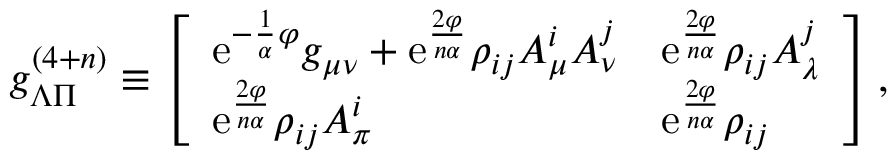Convert formula to latex. <formula><loc_0><loc_0><loc_500><loc_500>g _ { \Lambda \Pi } ^ { ( 4 + n ) } \equiv \left [ \begin{array} { l l } { { e ^ { - { \frac { 1 } { \alpha } } \varphi } g _ { \mu \nu } + e ^ { \frac { 2 \varphi } { n \alpha } } \rho _ { i j } A _ { \mu } ^ { i } A _ { \nu } ^ { j } } } & { { e ^ { \frac { 2 \varphi } { n \alpha } } \rho _ { i j } A _ { \lambda } ^ { j } } } \\ { { e ^ { \frac { 2 \varphi } { n \alpha } } \rho _ { i j } A _ { \pi } ^ { i } } } & { { e ^ { \frac { 2 \varphi } { n \alpha } } \rho _ { i j } } } \end{array} \right ] ,</formula> 